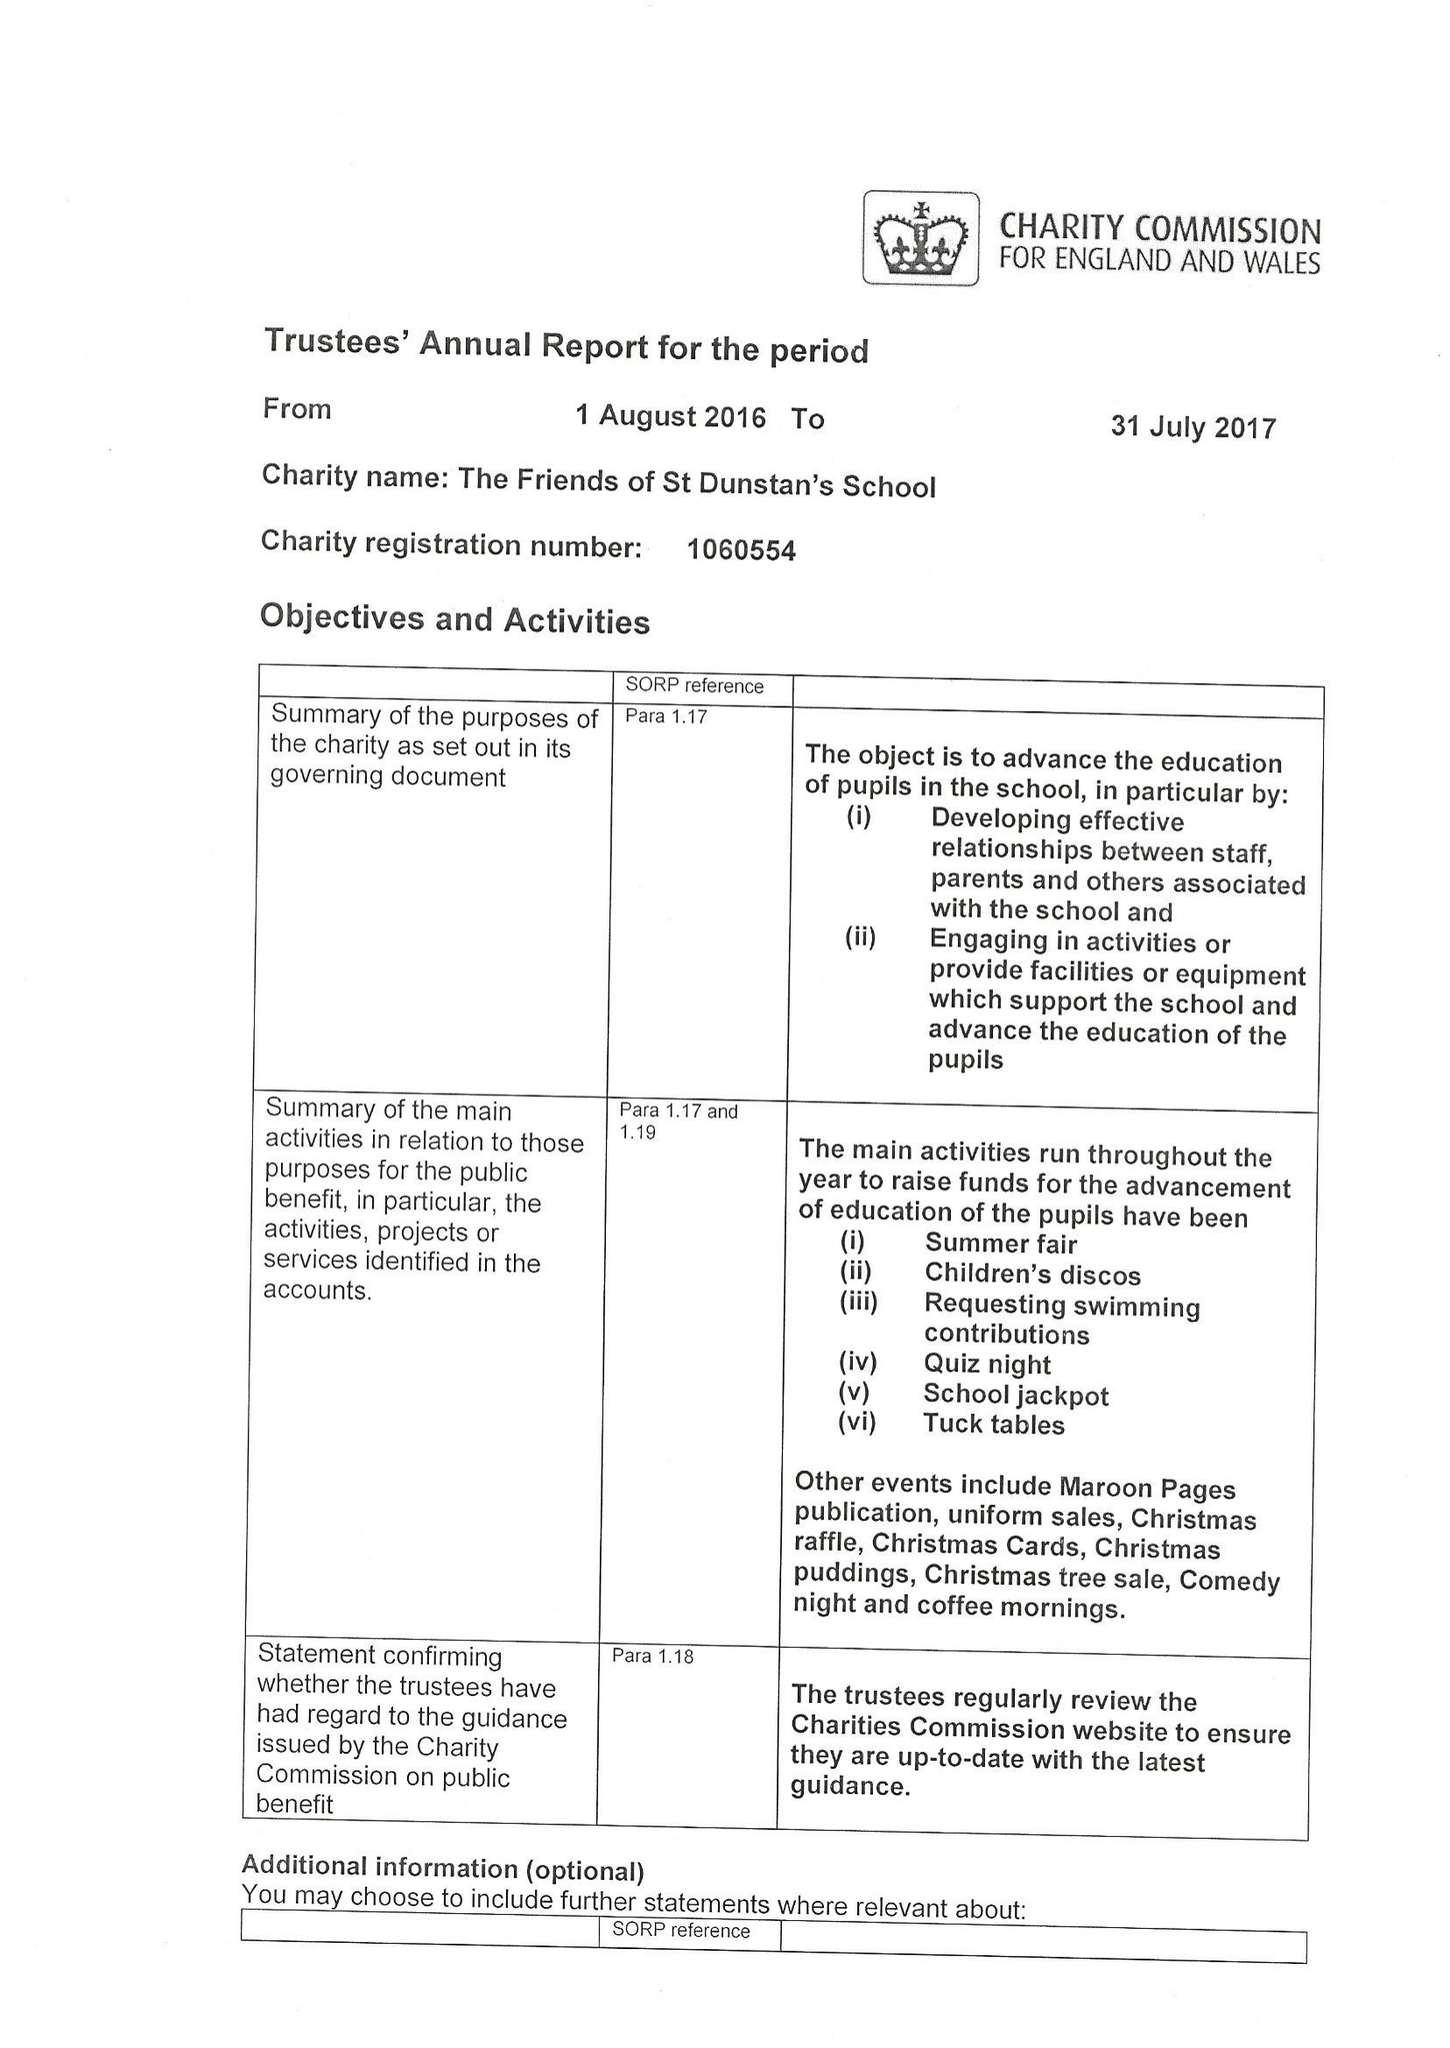What is the value for the income_annually_in_british_pounds?
Answer the question using a single word or phrase. 43397.00 